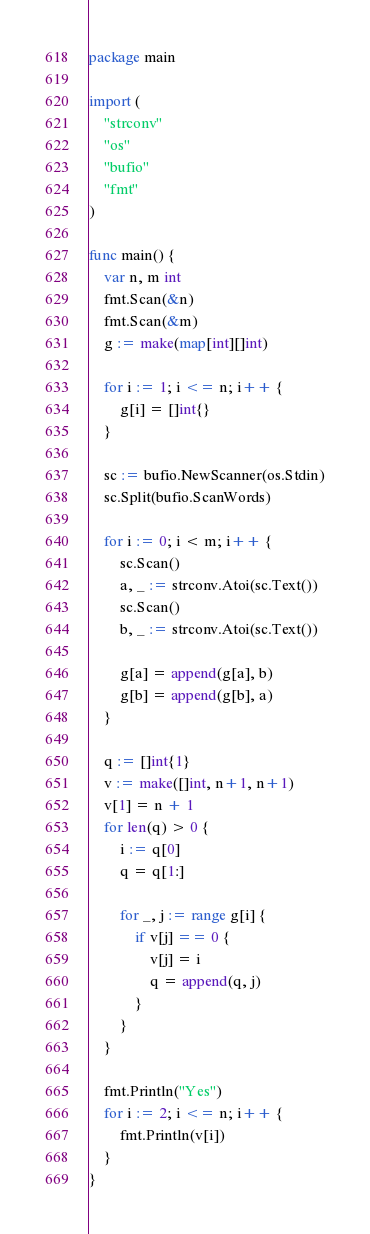Convert code to text. <code><loc_0><loc_0><loc_500><loc_500><_Go_>package main

import (
	"strconv"
	"os"
	"bufio"
	"fmt"
)

func main() {
	var n, m int
	fmt.Scan(&n)
	fmt.Scan(&m)
	g := make(map[int][]int)

	for i := 1; i <= n; i++ {
		g[i] = []int{}
	}

	sc := bufio.NewScanner(os.Stdin)
	sc.Split(bufio.ScanWords)

	for i := 0; i < m; i++ {
		sc.Scan()
		a, _ := strconv.Atoi(sc.Text())
		sc.Scan()
		b, _ := strconv.Atoi(sc.Text())

		g[a] = append(g[a], b)
		g[b] = append(g[b], a)
	}

	q := []int{1}
	v := make([]int, n+1, n+1)
	v[1] = n + 1
	for len(q) > 0 {
		i := q[0]
		q = q[1:]

		for _, j := range g[i] {
			if v[j] == 0 {
				v[j] = i
				q = append(q, j)
			}
		}
	}

	fmt.Println("Yes")
	for i := 2; i <= n; i++ {
		fmt.Println(v[i])
	}
}
</code> 